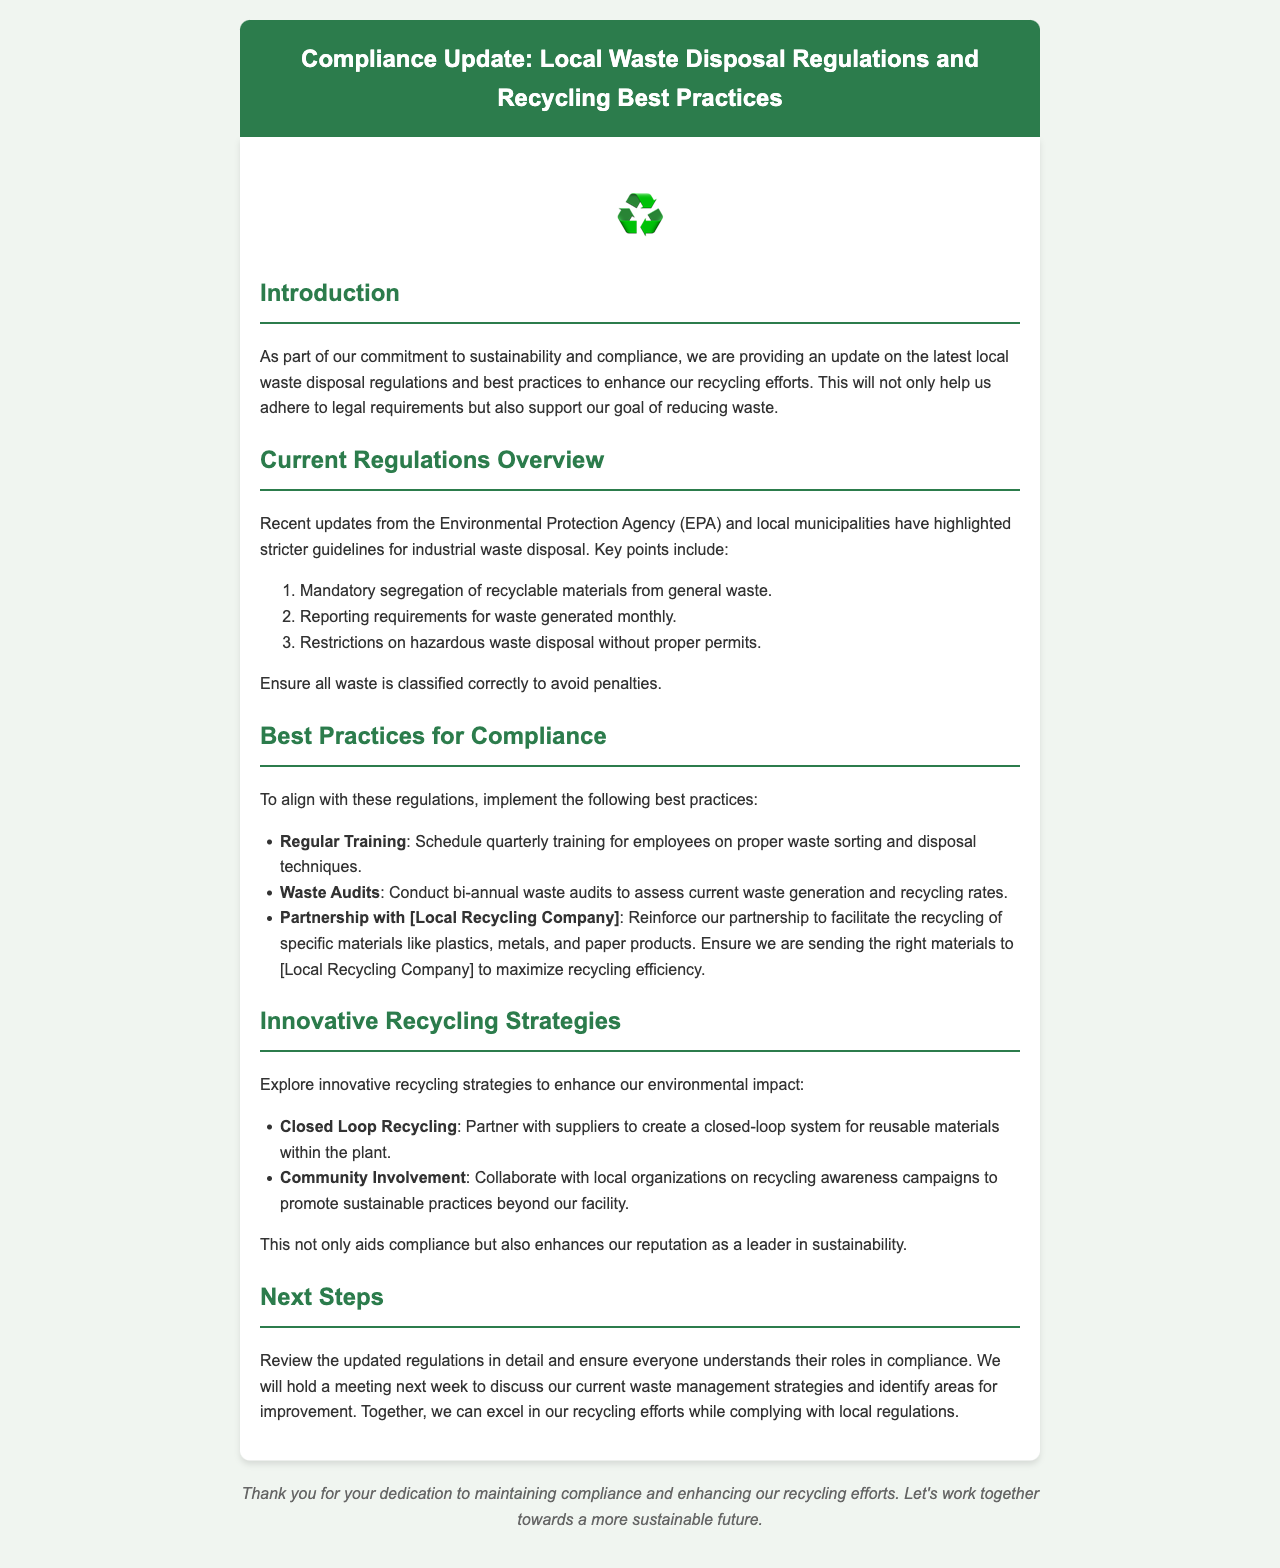What is the purpose of the email? The purpose of the email is to provide an update on local waste disposal regulations and best practices for recycling.
Answer: Compliance update Which organization issued the recent updates on waste disposal regulations? The recent updates were issued by the Environmental Protection Agency (EPA) and local municipalities.
Answer: Environmental Protection Agency How often should employees receive training on waste sorting? Employees should receive training on proper waste sorting quarterly.
Answer: Quarterly What is one of the restrictions mentioned for waste disposal? One of the restrictions is on hazardous waste disposal without proper permits.
Answer: Restrictions on hazardous waste How frequently should waste audits be conducted? Waste audits should be conducted bi-annually to assess current waste generation and recycling rates.
Answer: Bi-annually What is a suggested innovative recycling strategy? A suggested innovative recycling strategy is to partner with suppliers for a closed-loop recycling system.
Answer: Closed Loop Recycling When will the meeting to discuss waste management strategies be held? The meeting to discuss current waste management strategies will be held next week.
Answer: Next week What type of materials should be sent to the local recycling company? Specific materials like plastics, metals, and paper products should be sent to the local recycling company.
Answer: Plastics, metals, and paper products 